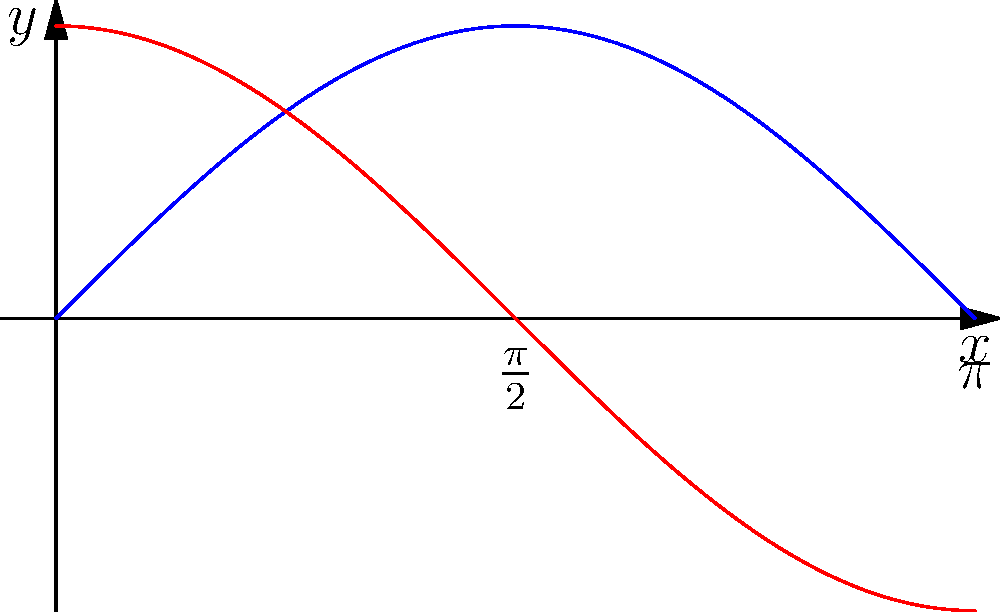As a novice writer preparing for your podcast on trigonometry, you want to demonstrate how to simplify complex expressions using trigonometric identities. Simplify the following expression:

$$\frac{\sin^2 x + \cos^2 x}{\tan x + \cot x}$$ Let's approach this step-by-step:

1) First, recall the fundamental trigonometric identity:
   $$\sin^2 x + \cos^2 x = 1$$

2) This simplifies our numerator to 1:
   $$\frac{1}{\tan x + \cot x}$$

3) Now, let's focus on the denominator. Recall the definitions of $\tan x$ and $\cot x$:
   $$\tan x = \frac{\sin x}{\cos x}$$
   $$\cot x = \frac{\cos x}{\sin x}$$

4) Substituting these into our expression:
   $$\frac{1}{\frac{\sin x}{\cos x} + \frac{\cos x}{\sin x}}$$

5) To add these fractions, we need a common denominator. Multiply each term by $\frac{\sin x \cos x}{\sin x \cos x}$:
   $$\frac{1}{\frac{\sin^2 x}{\sin x \cos x} + \frac{\cos^2 x}{\sin x \cos x}}$$

6) Simplify:
   $$\frac{1}{\frac{\sin^2 x + \cos^2 x}{\sin x \cos x}}$$

7) Recall from step 1 that $\sin^2 x + \cos^2 x = 1$:
   $$\frac{1}{\frac{1}{\sin x \cos x}}$$

8) When dividing by a fraction, we multiply by its reciprocal:
   $$1 \cdot \sin x \cos x = \sin x \cos x$$

Therefore, the simplified expression is $\sin x \cos x$.
Answer: $\sin x \cos x$ 